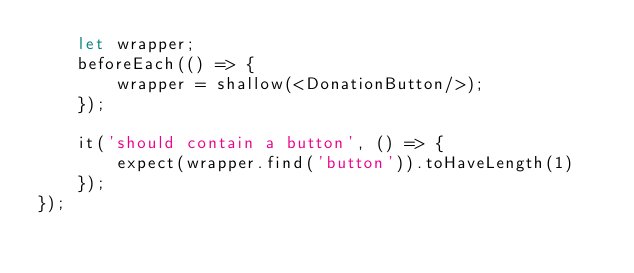<code> <loc_0><loc_0><loc_500><loc_500><_JavaScript_>    let wrapper;
    beforeEach(() => {
        wrapper = shallow(<DonationButton/>);
    });

    it('should contain a button', () => {
        expect(wrapper.find('button')).toHaveLength(1)
    });
});
</code> 